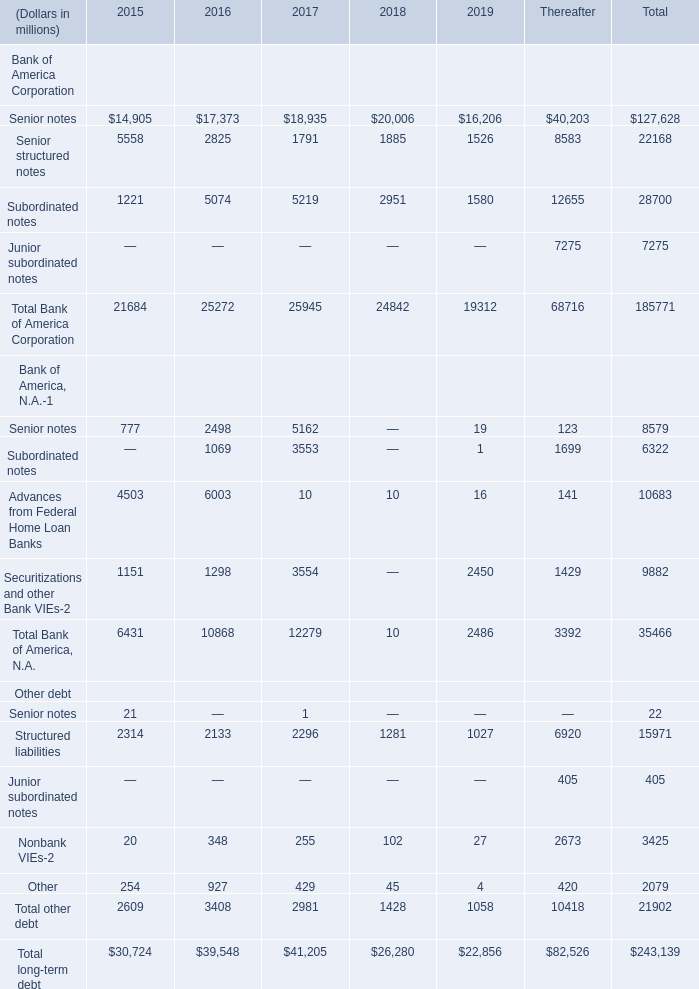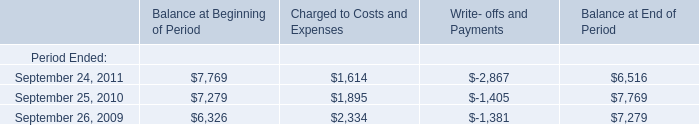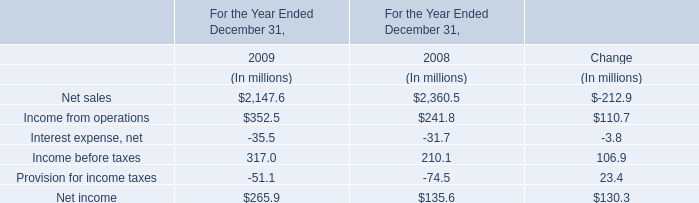What is the sum of Structured liabilities in 2017 and September 25, 2010 for Charged to Costs and Expenses? (in million) 
Computations: (2296 + 1895)
Answer: 4191.0. 